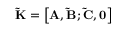Convert formula to latex. <formula><loc_0><loc_0><loc_500><loc_500>\tilde { K } = \left [ { { A } , \tilde { B } ; \tilde { C } , { 0 } } \right ]</formula> 